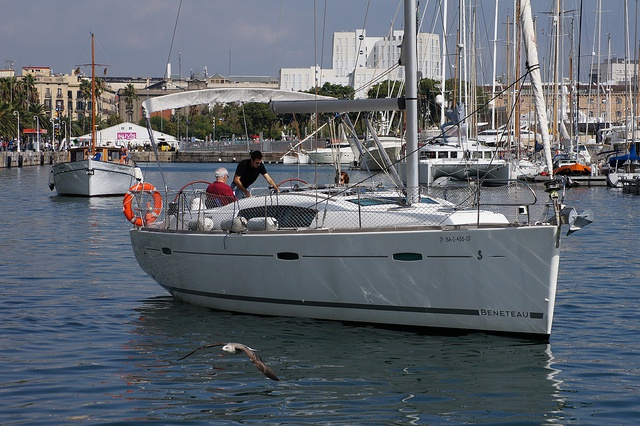Describe the objects in this image and their specific colors. I can see boat in gray, black, darkgray, and lightgray tones, boat in gray, darkgray, and lightgray tones, boat in gray, darkgray, lightgray, and black tones, boat in gray, black, darkgray, and lightgray tones, and people in gray, black, and maroon tones in this image. 